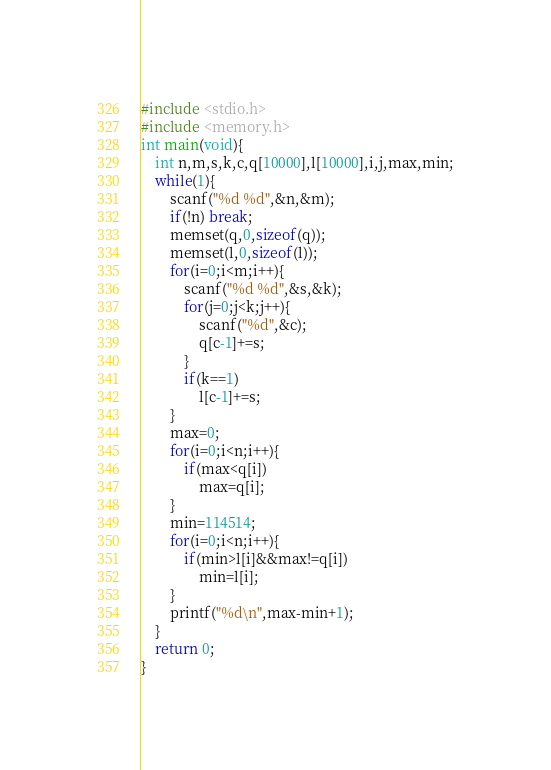<code> <loc_0><loc_0><loc_500><loc_500><_C_>#include <stdio.h>
#include <memory.h>
int main(void){
	int n,m,s,k,c,q[10000],l[10000],i,j,max,min;
	while(1){
		scanf("%d %d",&n,&m);
		if(!n) break;
		memset(q,0,sizeof(q));
		memset(l,0,sizeof(l));
		for(i=0;i<m;i++){
			scanf("%d %d",&s,&k);
			for(j=0;j<k;j++){
				scanf("%d",&c);
				q[c-1]+=s;
			}
			if(k==1)
				l[c-1]+=s;
		}
		max=0;
		for(i=0;i<n;i++){
			if(max<q[i])
				max=q[i];
		}
		min=114514;
		for(i=0;i<n;i++){
			if(min>l[i]&&max!=q[i])
				min=l[i];
		}
		printf("%d\n",max-min+1);
	}
	return 0;
}</code> 